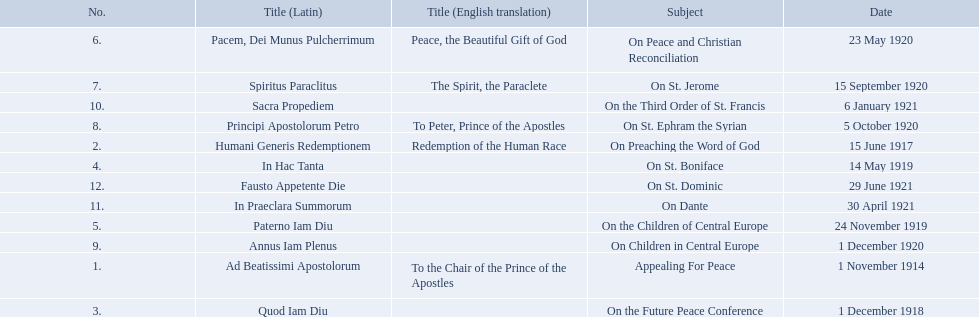What are all the subjects? Appealing For Peace, On Preaching the Word of God, On the Future Peace Conference, On St. Boniface, On the Children of Central Europe, On Peace and Christian Reconciliation, On St. Jerome, On St. Ephram the Syrian, On Children in Central Europe, On the Third Order of St. Francis, On Dante, On St. Dominic. Which occurred in 1920? On Peace and Christian Reconciliation, On St. Jerome, On St. Ephram the Syrian, On Children in Central Europe. Which occurred in may of that year? On Peace and Christian Reconciliation. 